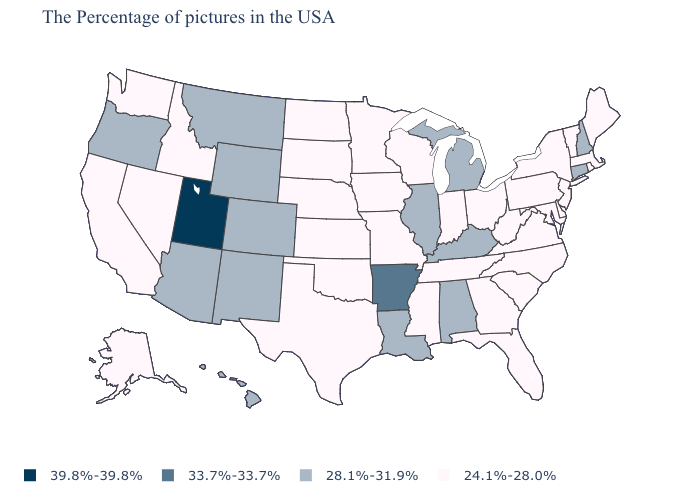Name the states that have a value in the range 39.8%-39.8%?
Be succinct. Utah. Does the map have missing data?
Concise answer only. No. Does Utah have the highest value in the USA?
Quick response, please. Yes. What is the value of Kentucky?
Quick response, please. 28.1%-31.9%. Which states have the lowest value in the USA?
Give a very brief answer. Maine, Massachusetts, Rhode Island, Vermont, New York, New Jersey, Delaware, Maryland, Pennsylvania, Virginia, North Carolina, South Carolina, West Virginia, Ohio, Florida, Georgia, Indiana, Tennessee, Wisconsin, Mississippi, Missouri, Minnesota, Iowa, Kansas, Nebraska, Oklahoma, Texas, South Dakota, North Dakota, Idaho, Nevada, California, Washington, Alaska. Among the states that border New Mexico , does Utah have the highest value?
Be succinct. Yes. Does Idaho have the same value as Tennessee?
Write a very short answer. Yes. Does the map have missing data?
Quick response, please. No. Does Utah have the highest value in the USA?
Short answer required. Yes. What is the lowest value in states that border Rhode Island?
Be succinct. 24.1%-28.0%. What is the value of South Dakota?
Give a very brief answer. 24.1%-28.0%. How many symbols are there in the legend?
Give a very brief answer. 4. Name the states that have a value in the range 28.1%-31.9%?
Write a very short answer. New Hampshire, Connecticut, Michigan, Kentucky, Alabama, Illinois, Louisiana, Wyoming, Colorado, New Mexico, Montana, Arizona, Oregon, Hawaii. 